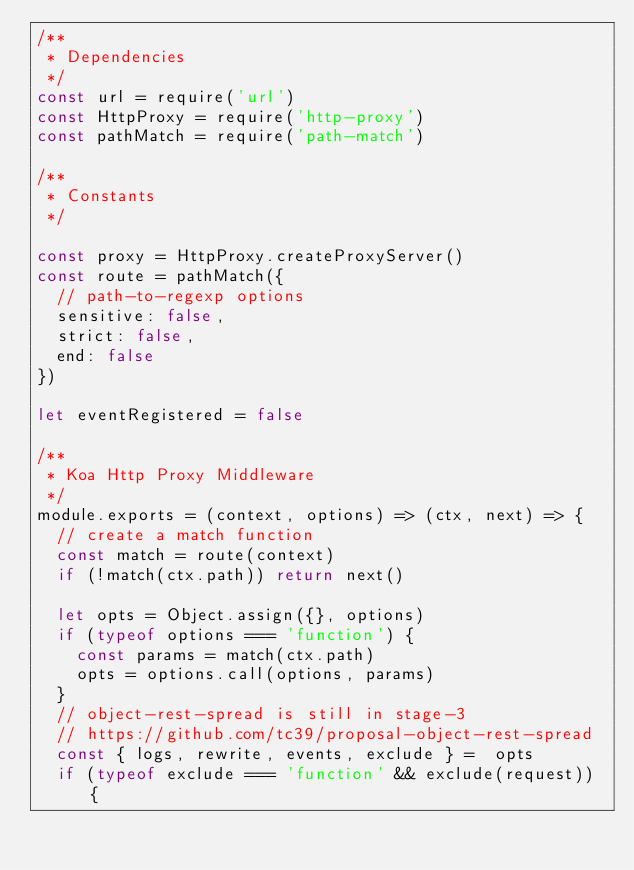Convert code to text. <code><loc_0><loc_0><loc_500><loc_500><_JavaScript_>/**
 * Dependencies
 */
const url = require('url')
const HttpProxy = require('http-proxy')
const pathMatch = require('path-match')

/**
 * Constants
 */

const proxy = HttpProxy.createProxyServer()
const route = pathMatch({
  // path-to-regexp options
  sensitive: false,
  strict: false,
  end: false
})

let eventRegistered = false

/**
 * Koa Http Proxy Middleware
 */
module.exports = (context, options) => (ctx, next) => {
  // create a match function
  const match = route(context)
  if (!match(ctx.path)) return next()

  let opts = Object.assign({}, options)
  if (typeof options === 'function') {
    const params = match(ctx.path)
    opts = options.call(options, params)
  }
  // object-rest-spread is still in stage-3
  // https://github.com/tc39/proposal-object-rest-spread
  const { logs, rewrite, events, exclude } =  opts
  if (typeof exclude === 'function' && exclude(request)) {</code> 